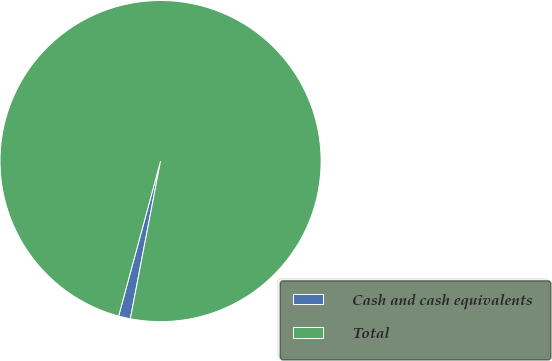Convert chart to OTSL. <chart><loc_0><loc_0><loc_500><loc_500><pie_chart><fcel>Cash and cash equivalents<fcel>Total<nl><fcel>1.19%<fcel>98.81%<nl></chart> 